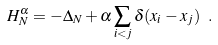<formula> <loc_0><loc_0><loc_500><loc_500>H _ { N } ^ { \alpha } = - \Delta _ { N } + \alpha \sum _ { i < j } \delta ( x _ { i } - x _ { j } ) \ .</formula> 